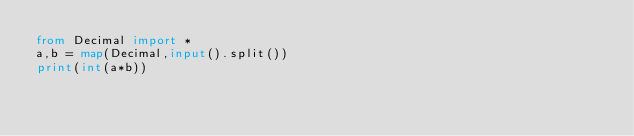<code> <loc_0><loc_0><loc_500><loc_500><_Python_>from Decimal import *
a,b = map(Decimal,input().split())
print(int(a*b))</code> 